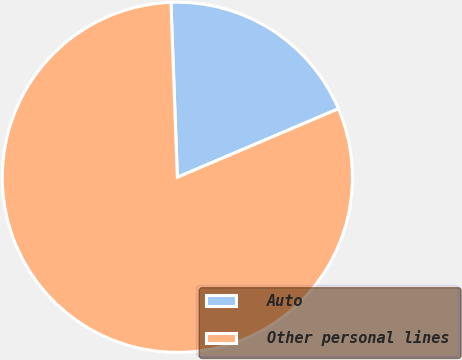Convert chart. <chart><loc_0><loc_0><loc_500><loc_500><pie_chart><fcel>Auto<fcel>Other personal lines<nl><fcel>19.18%<fcel>80.82%<nl></chart> 